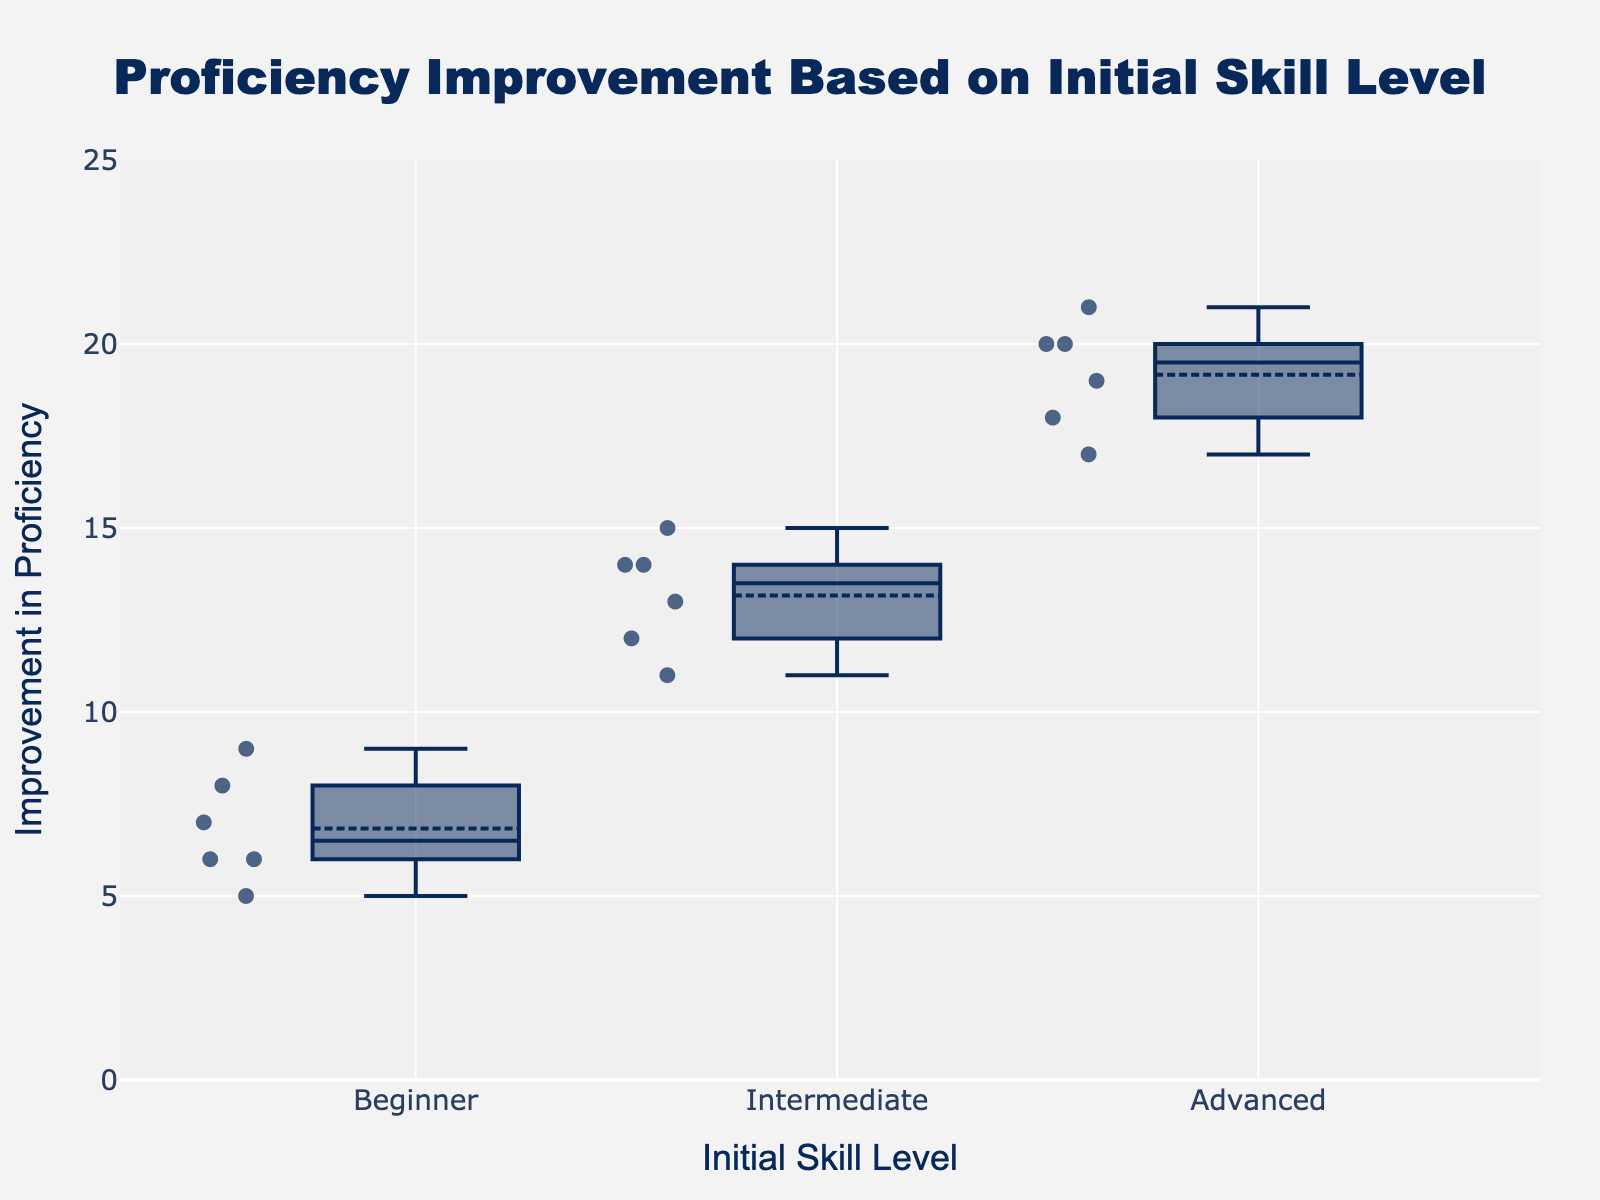What is the title of the plot? The title of the plot is written at the top of the figure.
Answer: Proficiency Improvement Based on Initial Skill Level What are the x-axis and y-axis labels? The x-axis label represents 'Initial Skill Level' and the y-axis label represents 'Improvement in Proficiency'.
Answer: Initial Skill Level; Improvement in Proficiency Which skill level group shows the highest improvement in proficiency on average? By observing the boxes' mean points (usually represented as a line within or around the box), the 'Advanced' group shows the highest values.
Answer: Advanced How many Beginner students' improvements are shown in the scatter points? By counting the scatter points within the 'Beginner' category, there are 6 points.
Answer: 6 What is the median improvement in proficiency for the Intermediate group? The median is the line inside the box plot for the 'Intermediate' group, typically located in the middle of the box.
Answer: 13 Compare the range of improvement between Intermediate and Advanced students. Which group has a wider range? The range is determined by the difference between the maximum and minimum values within the box plot. The 'Advanced' group clearly has a wider range (from 17 to 21) compared to the 'Intermediate' group (from 11 to 15).
Answer: Advanced What is the highest recorded improvement for the Beginner group? The highest value is the top point within the box plot for the 'Beginner' group, which looks to be 9.
Answer: 9 Which initial skill level group has the tightest IQR (Interquartile Range)? Observing all box plots, the 'Intermediate' group has the smallest box width which represents the IQR.
Answer: Intermediate How does the maximum improvement in proficiency of the Beginner group compare to the minimum improvement of the Intermediate group? The maximum value in the Beginner group does not exceed the minimum value in the Intermediate group.
Answer: Beginner < Intermediate What is the approximate improvement range for the Beginner group? By observing the minimum and maximum scatter points for the 'Beginner' group, the range is from 5 to 9.
Answer: 5 to 9 